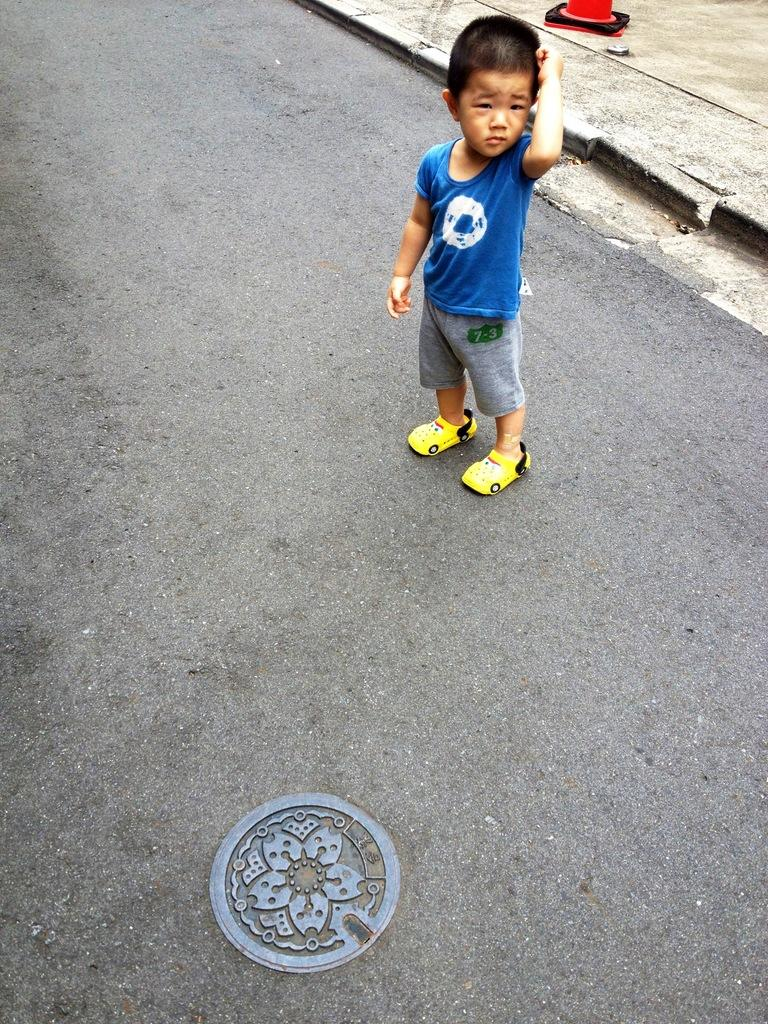What is the main subject of the image? The main subject of the image is a kid standing on the road. What can be seen at the top of the image? There is a walkway visible at the top of the image, and a red object is also present there. What is located at the bottom of the image? There is a manhole at the bottom of the image. What type of cloth is being used to make cakes in the image? There is no cloth or cakes present in the image. 